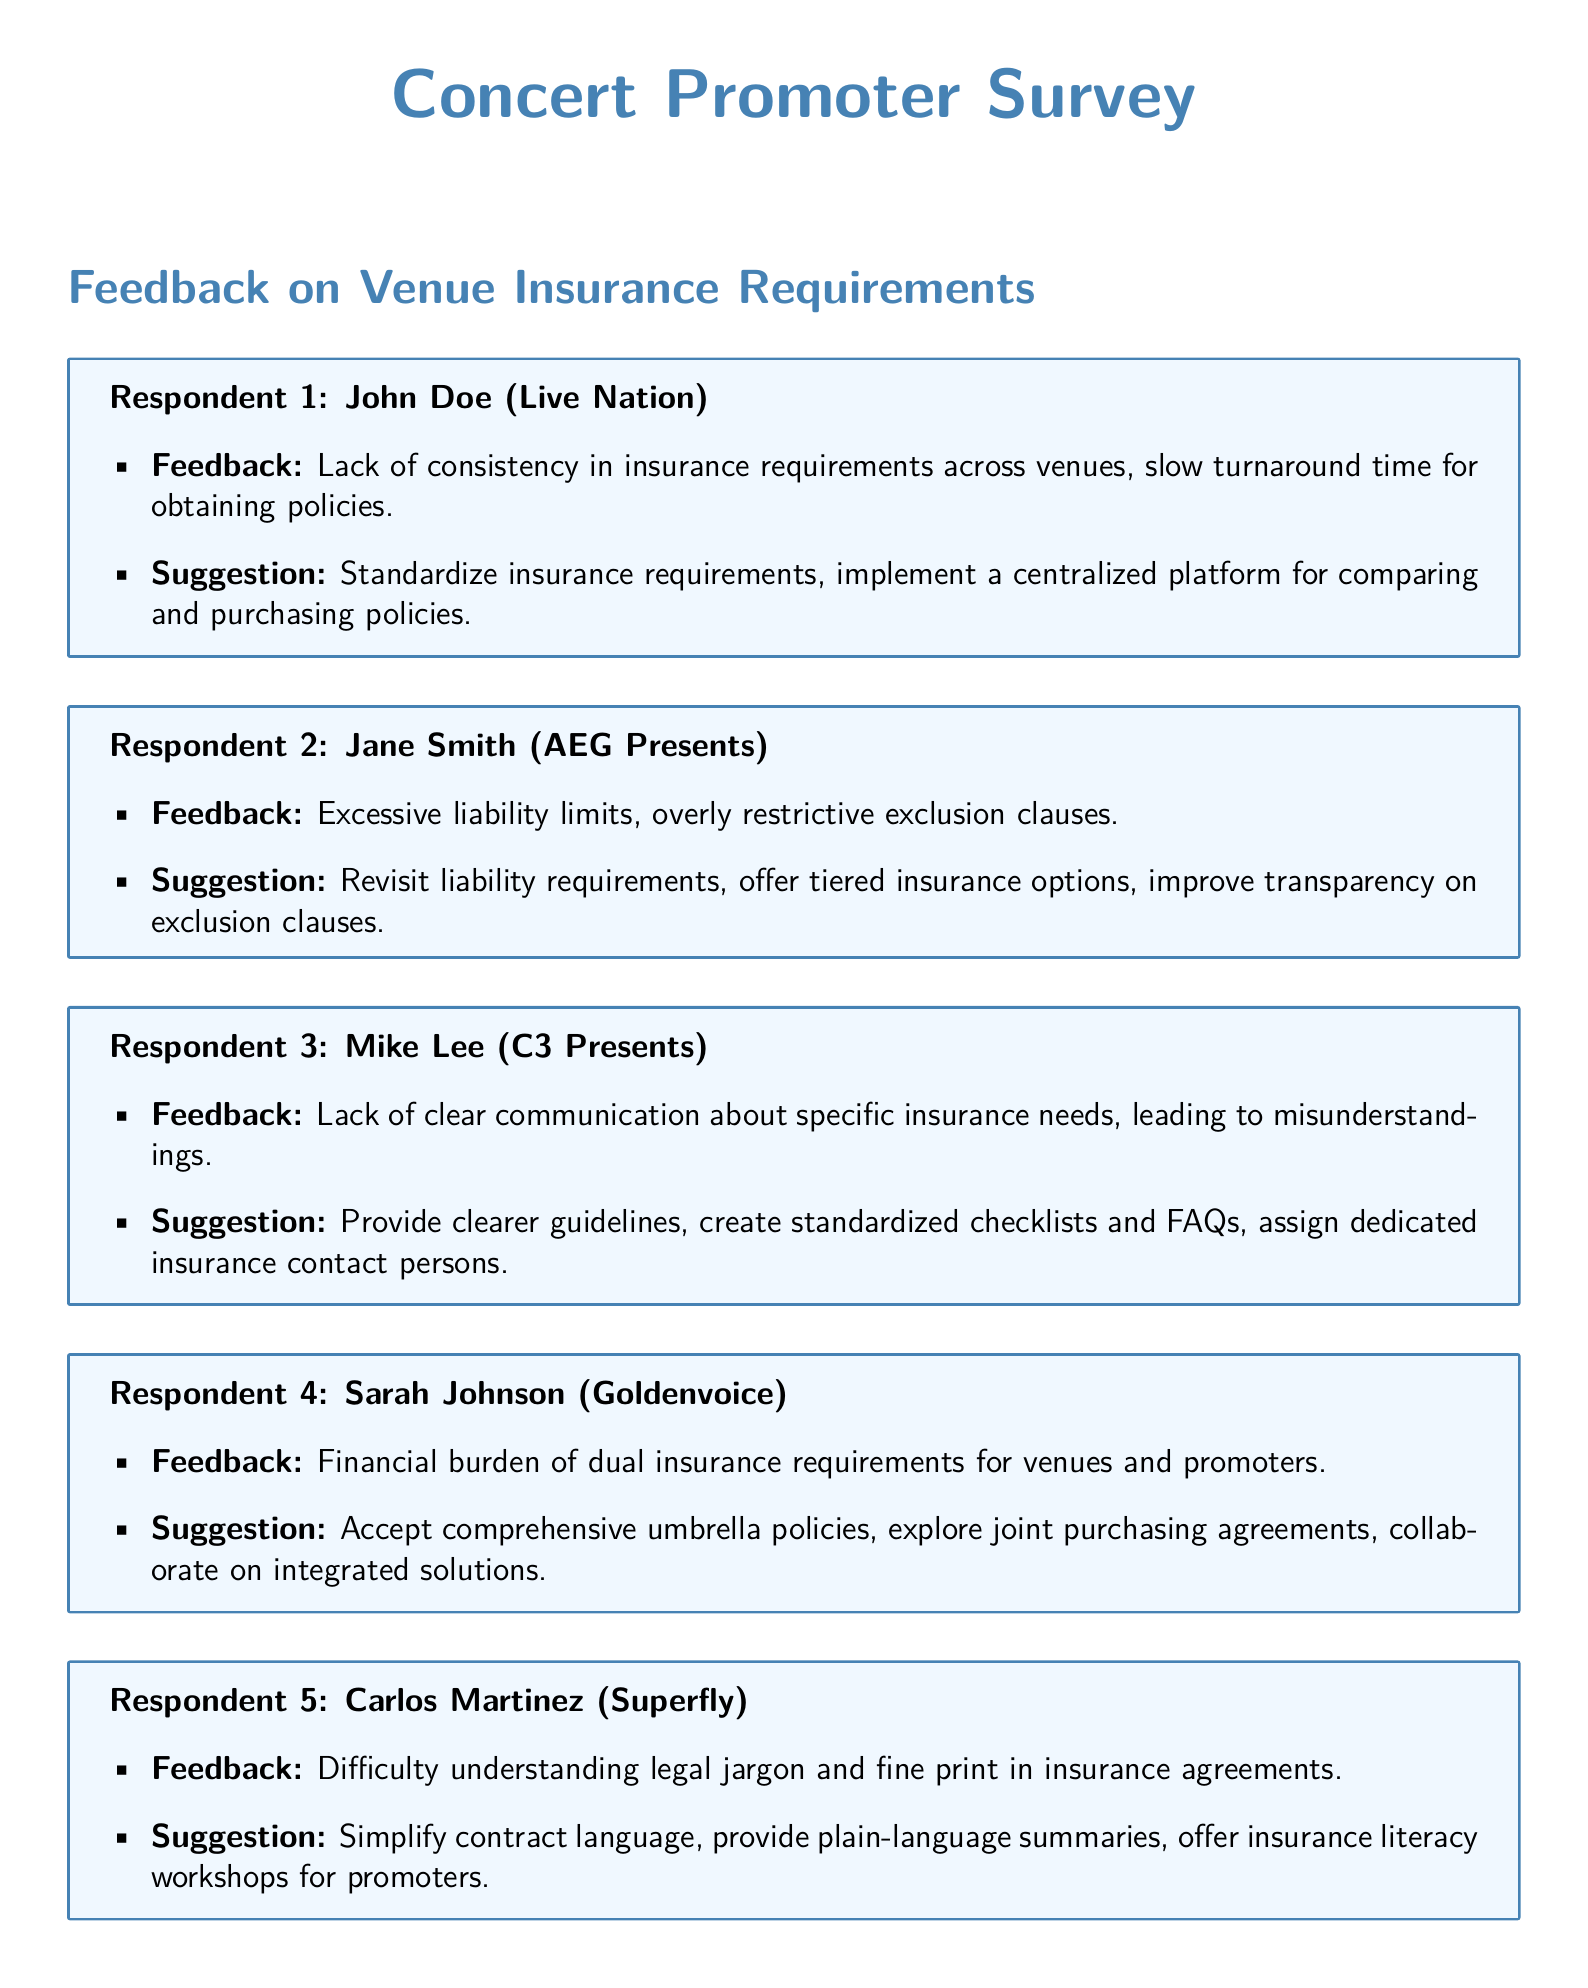What is John Doe's affiliation? John Doe is associated with Live Nation, as stated in the document.
Answer: Live Nation What is one of Jane Smith's concerns regarding insurance requirements? Jane Smith mentioned excessive liability limits in her feedback.
Answer: Excessive liability limits What suggestion did Mike Lee make to improve communication? Mike Lee suggested providing clearer guidelines and creating standardized checklists.
Answer: Clearer guidelines How many respondents are mentioned in the document? The document lists a total of five respondents who provided feedback.
Answer: Five What is Carlos Martinez's profession? Carlos Martinez is affiliated with Superfly, as per the survey.
Answer: Superfly What did Sarah Johnson suggest to alleviate financial burdens? Sarah Johnson suggested accepting comprehensive umbrella policies.
Answer: Comprehensive umbrella policies What is a common theme in the suggestions from respondents? Many respondents suggest improvements in clarity or standardization of insurance requirements.
Answer: Clarity or standardization What issue does Mike Lee highlight regarding insurance needs? Mike Lee highlighted the lack of clear communication about specific insurance needs.
Answer: Lack of clear communication What was a financial concern raised by Sarah Johnson? Sarah Johnson raised concerns about the financial burden of dual insurance requirements.
Answer: Financial burden of dual insurance requirements 